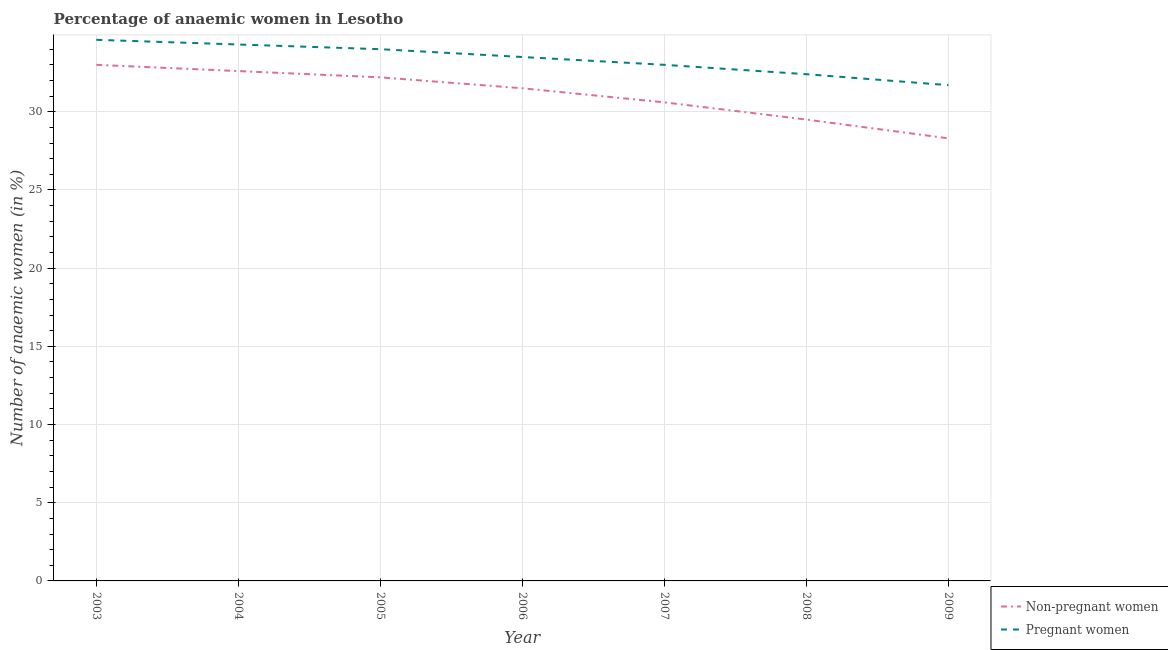Does the line corresponding to percentage of pregnant anaemic women intersect with the line corresponding to percentage of non-pregnant anaemic women?
Your answer should be very brief. No. What is the percentage of non-pregnant anaemic women in 2008?
Provide a succinct answer. 29.5. Across all years, what is the maximum percentage of non-pregnant anaemic women?
Provide a succinct answer. 33. Across all years, what is the minimum percentage of pregnant anaemic women?
Provide a succinct answer. 31.7. In which year was the percentage of non-pregnant anaemic women minimum?
Your answer should be very brief. 2009. What is the total percentage of non-pregnant anaemic women in the graph?
Your response must be concise. 217.7. What is the difference between the percentage of pregnant anaemic women in 2003 and that in 2005?
Provide a succinct answer. 0.6. What is the difference between the percentage of pregnant anaemic women in 2004 and the percentage of non-pregnant anaemic women in 2006?
Offer a terse response. 2.8. What is the average percentage of non-pregnant anaemic women per year?
Provide a succinct answer. 31.1. In the year 2006, what is the difference between the percentage of non-pregnant anaemic women and percentage of pregnant anaemic women?
Your response must be concise. -2. In how many years, is the percentage of non-pregnant anaemic women greater than 1 %?
Provide a short and direct response. 7. What is the ratio of the percentage of non-pregnant anaemic women in 2003 to that in 2007?
Offer a terse response. 1.08. Is the difference between the percentage of pregnant anaemic women in 2003 and 2008 greater than the difference between the percentage of non-pregnant anaemic women in 2003 and 2008?
Provide a succinct answer. No. What is the difference between the highest and the second highest percentage of non-pregnant anaemic women?
Make the answer very short. 0.4. What is the difference between the highest and the lowest percentage of pregnant anaemic women?
Your response must be concise. 2.9. Does the percentage of non-pregnant anaemic women monotonically increase over the years?
Provide a short and direct response. No. Is the percentage of pregnant anaemic women strictly greater than the percentage of non-pregnant anaemic women over the years?
Your answer should be compact. Yes. Is the percentage of pregnant anaemic women strictly less than the percentage of non-pregnant anaemic women over the years?
Offer a terse response. No. Does the graph contain grids?
Give a very brief answer. Yes. Where does the legend appear in the graph?
Provide a succinct answer. Bottom right. How many legend labels are there?
Keep it short and to the point. 2. How are the legend labels stacked?
Offer a terse response. Vertical. What is the title of the graph?
Provide a short and direct response. Percentage of anaemic women in Lesotho. Does "Investment in Transport" appear as one of the legend labels in the graph?
Give a very brief answer. No. What is the label or title of the X-axis?
Give a very brief answer. Year. What is the label or title of the Y-axis?
Ensure brevity in your answer.  Number of anaemic women (in %). What is the Number of anaemic women (in %) of Non-pregnant women in 2003?
Offer a very short reply. 33. What is the Number of anaemic women (in %) in Pregnant women in 2003?
Offer a terse response. 34.6. What is the Number of anaemic women (in %) in Non-pregnant women in 2004?
Provide a short and direct response. 32.6. What is the Number of anaemic women (in %) in Pregnant women in 2004?
Your response must be concise. 34.3. What is the Number of anaemic women (in %) of Non-pregnant women in 2005?
Offer a terse response. 32.2. What is the Number of anaemic women (in %) in Pregnant women in 2005?
Offer a very short reply. 34. What is the Number of anaemic women (in %) in Non-pregnant women in 2006?
Your answer should be compact. 31.5. What is the Number of anaemic women (in %) of Pregnant women in 2006?
Your answer should be very brief. 33.5. What is the Number of anaemic women (in %) of Non-pregnant women in 2007?
Offer a very short reply. 30.6. What is the Number of anaemic women (in %) of Non-pregnant women in 2008?
Give a very brief answer. 29.5. What is the Number of anaemic women (in %) of Pregnant women in 2008?
Offer a very short reply. 32.4. What is the Number of anaemic women (in %) of Non-pregnant women in 2009?
Give a very brief answer. 28.3. What is the Number of anaemic women (in %) in Pregnant women in 2009?
Give a very brief answer. 31.7. Across all years, what is the maximum Number of anaemic women (in %) of Pregnant women?
Your answer should be compact. 34.6. Across all years, what is the minimum Number of anaemic women (in %) of Non-pregnant women?
Your answer should be very brief. 28.3. Across all years, what is the minimum Number of anaemic women (in %) of Pregnant women?
Ensure brevity in your answer.  31.7. What is the total Number of anaemic women (in %) of Non-pregnant women in the graph?
Your answer should be compact. 217.7. What is the total Number of anaemic women (in %) in Pregnant women in the graph?
Give a very brief answer. 233.5. What is the difference between the Number of anaemic women (in %) in Non-pregnant women in 2003 and that in 2004?
Provide a succinct answer. 0.4. What is the difference between the Number of anaemic women (in %) of Pregnant women in 2003 and that in 2004?
Provide a succinct answer. 0.3. What is the difference between the Number of anaemic women (in %) in Pregnant women in 2003 and that in 2005?
Offer a very short reply. 0.6. What is the difference between the Number of anaemic women (in %) of Non-pregnant women in 2003 and that in 2006?
Provide a short and direct response. 1.5. What is the difference between the Number of anaemic women (in %) of Non-pregnant women in 2003 and that in 2007?
Ensure brevity in your answer.  2.4. What is the difference between the Number of anaemic women (in %) of Non-pregnant women in 2003 and that in 2009?
Make the answer very short. 4.7. What is the difference between the Number of anaemic women (in %) of Pregnant women in 2003 and that in 2009?
Make the answer very short. 2.9. What is the difference between the Number of anaemic women (in %) of Non-pregnant women in 2004 and that in 2008?
Offer a terse response. 3.1. What is the difference between the Number of anaemic women (in %) in Non-pregnant women in 2004 and that in 2009?
Your answer should be compact. 4.3. What is the difference between the Number of anaemic women (in %) of Pregnant women in 2004 and that in 2009?
Make the answer very short. 2.6. What is the difference between the Number of anaemic women (in %) in Non-pregnant women in 2005 and that in 2006?
Your response must be concise. 0.7. What is the difference between the Number of anaemic women (in %) in Pregnant women in 2005 and that in 2006?
Keep it short and to the point. 0.5. What is the difference between the Number of anaemic women (in %) in Non-pregnant women in 2005 and that in 2007?
Make the answer very short. 1.6. What is the difference between the Number of anaemic women (in %) in Non-pregnant women in 2005 and that in 2008?
Provide a short and direct response. 2.7. What is the difference between the Number of anaemic women (in %) of Pregnant women in 2005 and that in 2008?
Provide a succinct answer. 1.6. What is the difference between the Number of anaemic women (in %) of Non-pregnant women in 2006 and that in 2007?
Offer a very short reply. 0.9. What is the difference between the Number of anaemic women (in %) of Pregnant women in 2006 and that in 2008?
Offer a terse response. 1.1. What is the difference between the Number of anaemic women (in %) in Non-pregnant women in 2007 and that in 2008?
Give a very brief answer. 1.1. What is the difference between the Number of anaemic women (in %) in Pregnant women in 2007 and that in 2008?
Provide a succinct answer. 0.6. What is the difference between the Number of anaemic women (in %) of Pregnant women in 2007 and that in 2009?
Your answer should be compact. 1.3. What is the difference between the Number of anaemic women (in %) of Non-pregnant women in 2003 and the Number of anaemic women (in %) of Pregnant women in 2004?
Give a very brief answer. -1.3. What is the difference between the Number of anaemic women (in %) of Non-pregnant women in 2003 and the Number of anaemic women (in %) of Pregnant women in 2006?
Your answer should be very brief. -0.5. What is the difference between the Number of anaemic women (in %) in Non-pregnant women in 2003 and the Number of anaemic women (in %) in Pregnant women in 2007?
Ensure brevity in your answer.  0. What is the difference between the Number of anaemic women (in %) in Non-pregnant women in 2003 and the Number of anaemic women (in %) in Pregnant women in 2009?
Your answer should be compact. 1.3. What is the difference between the Number of anaemic women (in %) of Non-pregnant women in 2004 and the Number of anaemic women (in %) of Pregnant women in 2005?
Provide a succinct answer. -1.4. What is the difference between the Number of anaemic women (in %) of Non-pregnant women in 2004 and the Number of anaemic women (in %) of Pregnant women in 2007?
Ensure brevity in your answer.  -0.4. What is the difference between the Number of anaemic women (in %) in Non-pregnant women in 2004 and the Number of anaemic women (in %) in Pregnant women in 2009?
Give a very brief answer. 0.9. What is the difference between the Number of anaemic women (in %) of Non-pregnant women in 2005 and the Number of anaemic women (in %) of Pregnant women in 2007?
Make the answer very short. -0.8. What is the difference between the Number of anaemic women (in %) in Non-pregnant women in 2006 and the Number of anaemic women (in %) in Pregnant women in 2007?
Your answer should be compact. -1.5. What is the difference between the Number of anaemic women (in %) in Non-pregnant women in 2006 and the Number of anaemic women (in %) in Pregnant women in 2008?
Give a very brief answer. -0.9. What is the difference between the Number of anaemic women (in %) of Non-pregnant women in 2006 and the Number of anaemic women (in %) of Pregnant women in 2009?
Offer a very short reply. -0.2. What is the difference between the Number of anaemic women (in %) in Non-pregnant women in 2007 and the Number of anaemic women (in %) in Pregnant women in 2009?
Make the answer very short. -1.1. What is the average Number of anaemic women (in %) in Non-pregnant women per year?
Offer a very short reply. 31.1. What is the average Number of anaemic women (in %) of Pregnant women per year?
Ensure brevity in your answer.  33.36. In the year 2003, what is the difference between the Number of anaemic women (in %) in Non-pregnant women and Number of anaemic women (in %) in Pregnant women?
Provide a succinct answer. -1.6. In the year 2004, what is the difference between the Number of anaemic women (in %) of Non-pregnant women and Number of anaemic women (in %) of Pregnant women?
Provide a short and direct response. -1.7. In the year 2005, what is the difference between the Number of anaemic women (in %) of Non-pregnant women and Number of anaemic women (in %) of Pregnant women?
Keep it short and to the point. -1.8. In the year 2006, what is the difference between the Number of anaemic women (in %) of Non-pregnant women and Number of anaemic women (in %) of Pregnant women?
Keep it short and to the point. -2. What is the ratio of the Number of anaemic women (in %) in Non-pregnant women in 2003 to that in 2004?
Make the answer very short. 1.01. What is the ratio of the Number of anaemic women (in %) of Pregnant women in 2003 to that in 2004?
Offer a terse response. 1.01. What is the ratio of the Number of anaemic women (in %) of Non-pregnant women in 2003 to that in 2005?
Offer a terse response. 1.02. What is the ratio of the Number of anaemic women (in %) of Pregnant women in 2003 to that in 2005?
Your response must be concise. 1.02. What is the ratio of the Number of anaemic women (in %) of Non-pregnant women in 2003 to that in 2006?
Provide a short and direct response. 1.05. What is the ratio of the Number of anaemic women (in %) in Pregnant women in 2003 to that in 2006?
Make the answer very short. 1.03. What is the ratio of the Number of anaemic women (in %) of Non-pregnant women in 2003 to that in 2007?
Provide a succinct answer. 1.08. What is the ratio of the Number of anaemic women (in %) in Pregnant women in 2003 to that in 2007?
Ensure brevity in your answer.  1.05. What is the ratio of the Number of anaemic women (in %) of Non-pregnant women in 2003 to that in 2008?
Offer a very short reply. 1.12. What is the ratio of the Number of anaemic women (in %) of Pregnant women in 2003 to that in 2008?
Your answer should be compact. 1.07. What is the ratio of the Number of anaemic women (in %) in Non-pregnant women in 2003 to that in 2009?
Give a very brief answer. 1.17. What is the ratio of the Number of anaemic women (in %) of Pregnant women in 2003 to that in 2009?
Provide a succinct answer. 1.09. What is the ratio of the Number of anaemic women (in %) in Non-pregnant women in 2004 to that in 2005?
Your answer should be compact. 1.01. What is the ratio of the Number of anaemic women (in %) of Pregnant women in 2004 to that in 2005?
Your response must be concise. 1.01. What is the ratio of the Number of anaemic women (in %) in Non-pregnant women in 2004 to that in 2006?
Keep it short and to the point. 1.03. What is the ratio of the Number of anaemic women (in %) of Pregnant women in 2004 to that in 2006?
Make the answer very short. 1.02. What is the ratio of the Number of anaemic women (in %) in Non-pregnant women in 2004 to that in 2007?
Give a very brief answer. 1.07. What is the ratio of the Number of anaemic women (in %) in Pregnant women in 2004 to that in 2007?
Offer a very short reply. 1.04. What is the ratio of the Number of anaemic women (in %) of Non-pregnant women in 2004 to that in 2008?
Provide a succinct answer. 1.11. What is the ratio of the Number of anaemic women (in %) of Pregnant women in 2004 to that in 2008?
Ensure brevity in your answer.  1.06. What is the ratio of the Number of anaemic women (in %) of Non-pregnant women in 2004 to that in 2009?
Your response must be concise. 1.15. What is the ratio of the Number of anaemic women (in %) in Pregnant women in 2004 to that in 2009?
Offer a very short reply. 1.08. What is the ratio of the Number of anaemic women (in %) in Non-pregnant women in 2005 to that in 2006?
Your answer should be very brief. 1.02. What is the ratio of the Number of anaemic women (in %) in Pregnant women in 2005 to that in 2006?
Make the answer very short. 1.01. What is the ratio of the Number of anaemic women (in %) in Non-pregnant women in 2005 to that in 2007?
Offer a very short reply. 1.05. What is the ratio of the Number of anaemic women (in %) in Pregnant women in 2005 to that in 2007?
Your answer should be very brief. 1.03. What is the ratio of the Number of anaemic women (in %) in Non-pregnant women in 2005 to that in 2008?
Your answer should be very brief. 1.09. What is the ratio of the Number of anaemic women (in %) of Pregnant women in 2005 to that in 2008?
Provide a short and direct response. 1.05. What is the ratio of the Number of anaemic women (in %) in Non-pregnant women in 2005 to that in 2009?
Your answer should be compact. 1.14. What is the ratio of the Number of anaemic women (in %) in Pregnant women in 2005 to that in 2009?
Offer a terse response. 1.07. What is the ratio of the Number of anaemic women (in %) of Non-pregnant women in 2006 to that in 2007?
Ensure brevity in your answer.  1.03. What is the ratio of the Number of anaemic women (in %) of Pregnant women in 2006 to that in 2007?
Your response must be concise. 1.02. What is the ratio of the Number of anaemic women (in %) in Non-pregnant women in 2006 to that in 2008?
Give a very brief answer. 1.07. What is the ratio of the Number of anaemic women (in %) of Pregnant women in 2006 to that in 2008?
Make the answer very short. 1.03. What is the ratio of the Number of anaemic women (in %) of Non-pregnant women in 2006 to that in 2009?
Your response must be concise. 1.11. What is the ratio of the Number of anaemic women (in %) in Pregnant women in 2006 to that in 2009?
Make the answer very short. 1.06. What is the ratio of the Number of anaemic women (in %) in Non-pregnant women in 2007 to that in 2008?
Provide a short and direct response. 1.04. What is the ratio of the Number of anaemic women (in %) of Pregnant women in 2007 to that in 2008?
Make the answer very short. 1.02. What is the ratio of the Number of anaemic women (in %) of Non-pregnant women in 2007 to that in 2009?
Make the answer very short. 1.08. What is the ratio of the Number of anaemic women (in %) in Pregnant women in 2007 to that in 2009?
Give a very brief answer. 1.04. What is the ratio of the Number of anaemic women (in %) of Non-pregnant women in 2008 to that in 2009?
Offer a very short reply. 1.04. What is the ratio of the Number of anaemic women (in %) in Pregnant women in 2008 to that in 2009?
Offer a terse response. 1.02. What is the difference between the highest and the lowest Number of anaemic women (in %) in Pregnant women?
Provide a succinct answer. 2.9. 